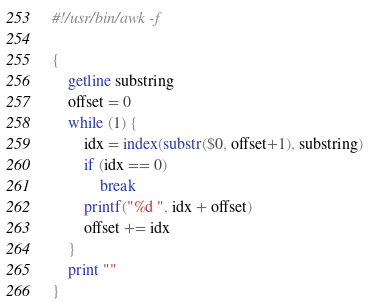<code> <loc_0><loc_0><loc_500><loc_500><_Awk_>#!/usr/bin/awk -f

{
    getline substring
    offset = 0
    while (1) {
        idx = index(substr($0, offset+1), substring) 
        if (idx == 0)
            break
        printf("%d ", idx + offset)
        offset += idx
    }
    print ""
}
</code> 